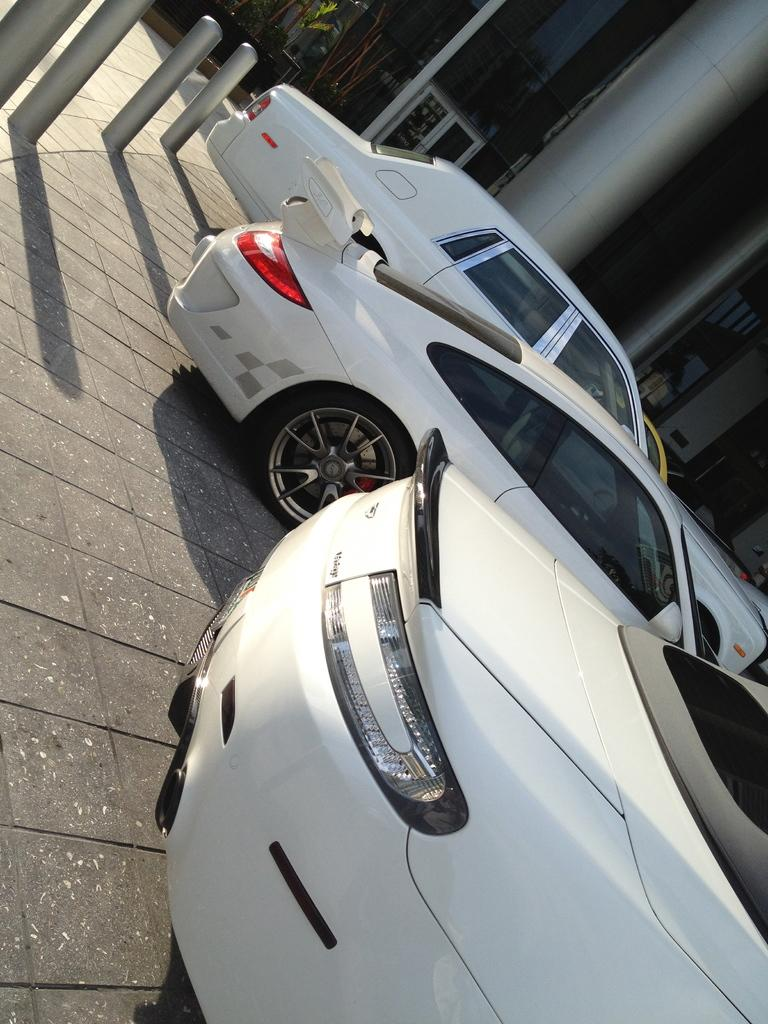How many cars are visible in the image? There are three white cars in the image. Where are the cars located in the image? The cars are parked on the road. What can be seen in the background of the image? There is a building in the background of the image. What is at the bottom of the image? The image shows a road at the bottom. What is present to the left of the image? There are small poles to the left of the image. Can you see a passenger inside any of the cars in the image? The image does not show any passengers inside the cars. What type of flower is blooming near the cars in the image? There are no flowers, including roses, present in the image. 